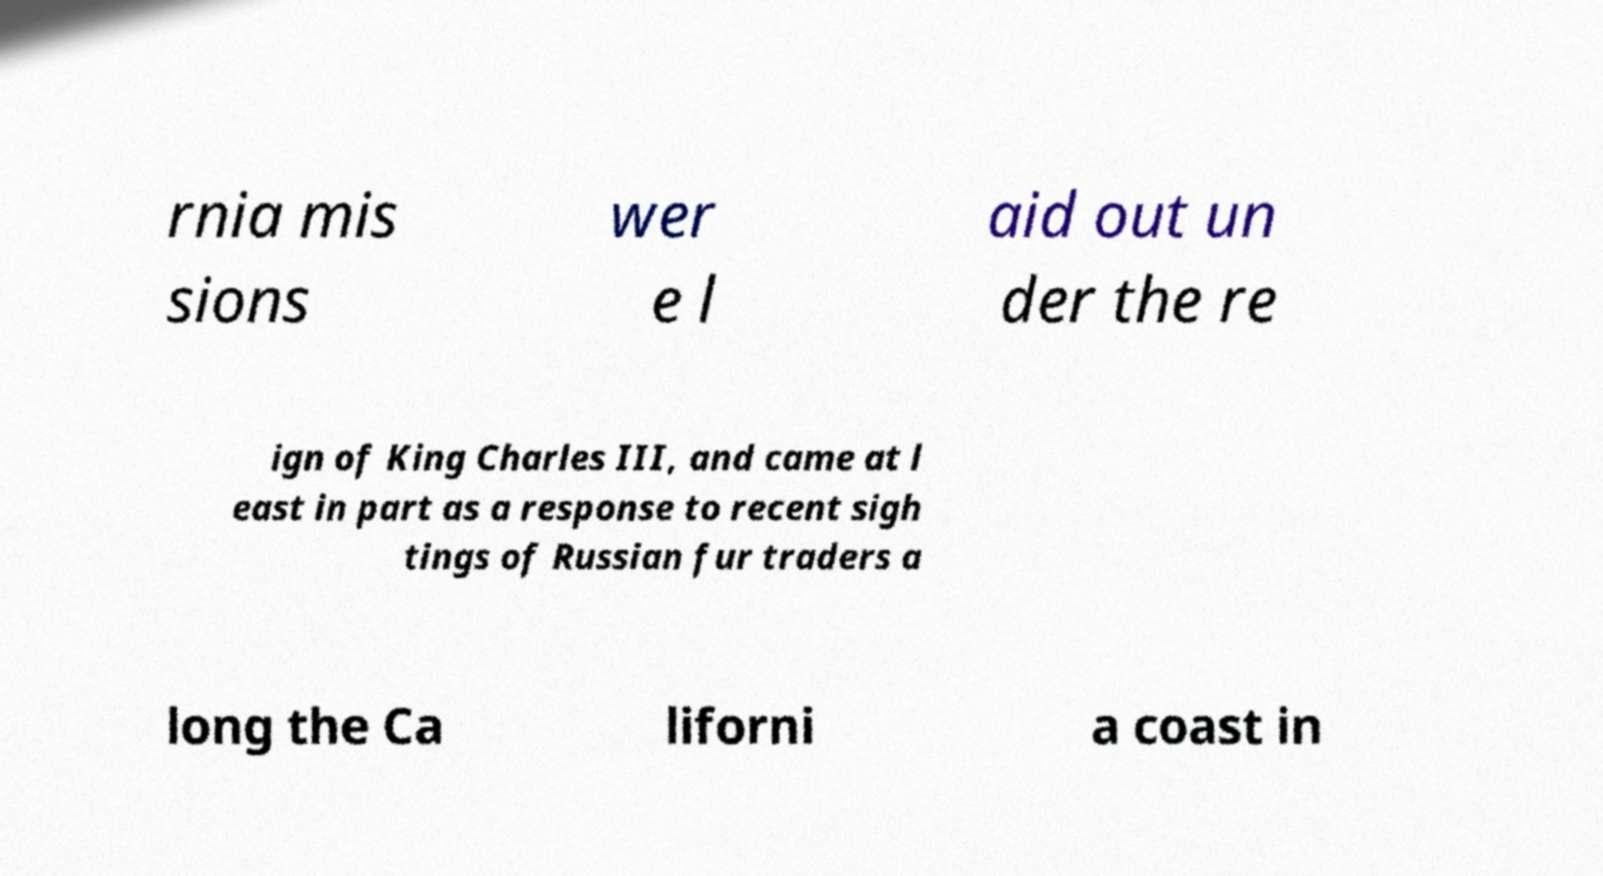What messages or text are displayed in this image? I need them in a readable, typed format. rnia mis sions wer e l aid out un der the re ign of King Charles III, and came at l east in part as a response to recent sigh tings of Russian fur traders a long the Ca liforni a coast in 